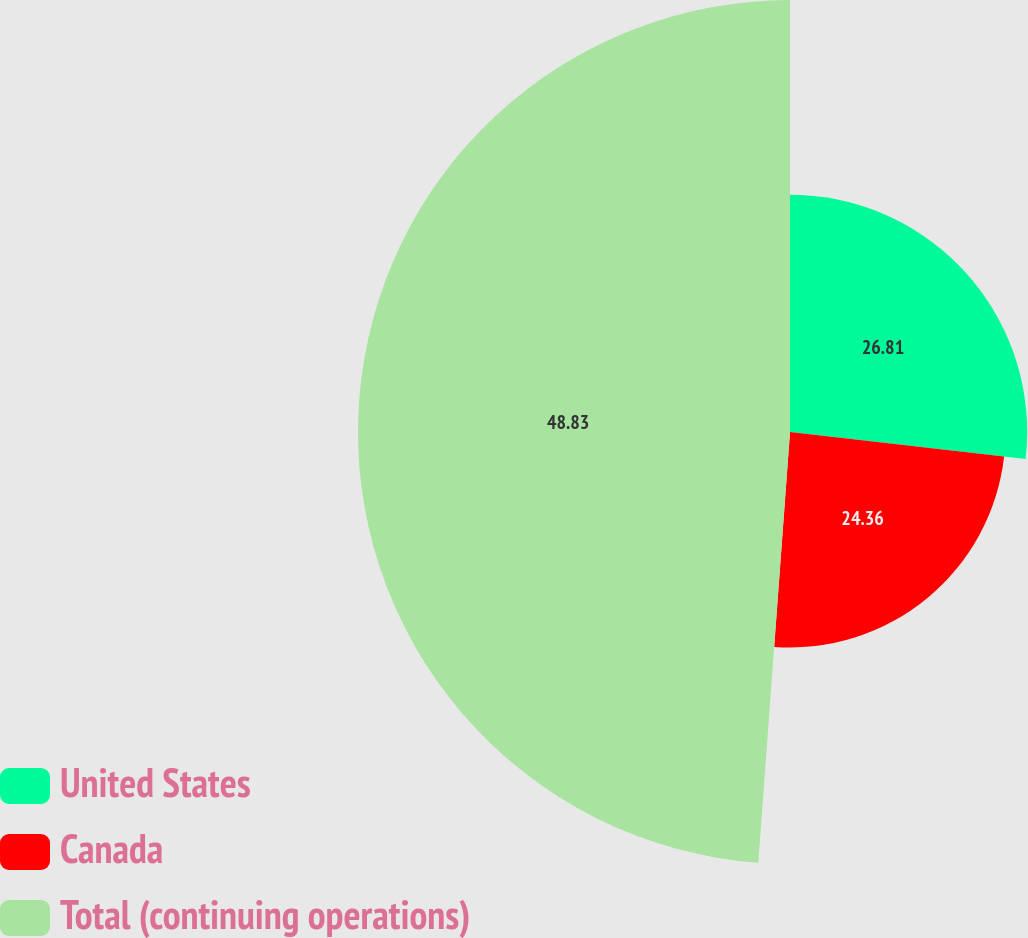Convert chart to OTSL. <chart><loc_0><loc_0><loc_500><loc_500><pie_chart><fcel>United States<fcel>Canada<fcel>Total (continuing operations)<nl><fcel>26.81%<fcel>24.36%<fcel>48.83%<nl></chart> 